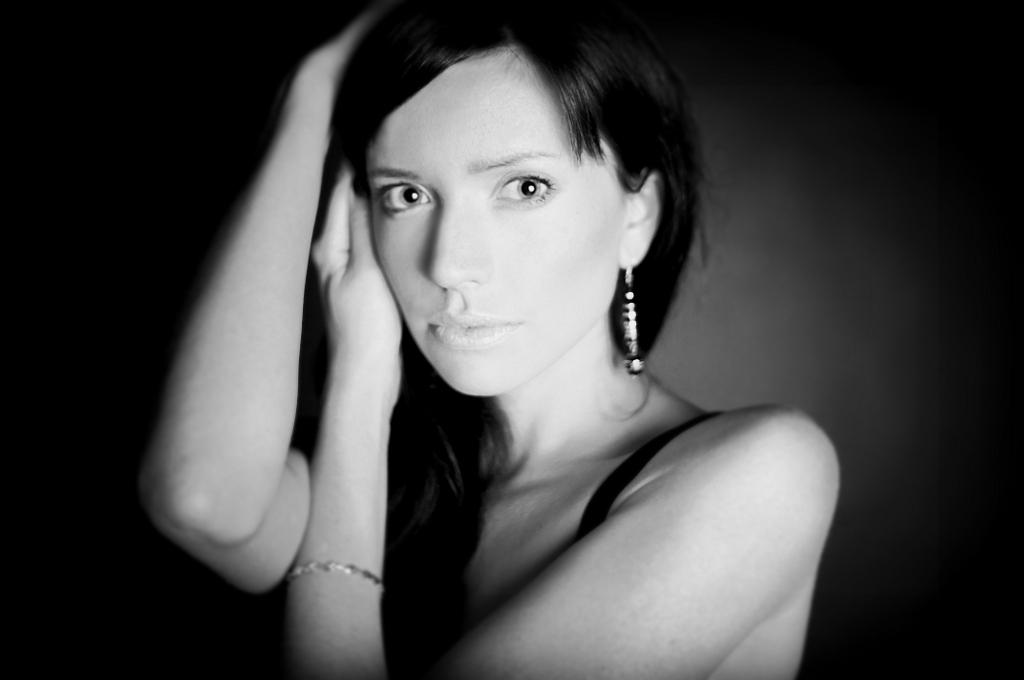Who is present in the image? There is a woman in the image. What is the color scheme of the image? The image is black and white. How many chickens are visible in the image? There are no chickens present in the image. What type of ship can be seen in the background of the image? There is no ship present in the image; it is a black and white image of a woman. 